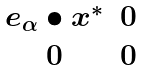Convert formula to latex. <formula><loc_0><loc_0><loc_500><loc_500>\begin{matrix} e _ { \alpha } \bullet x ^ { * } & 0 \\ 0 & 0 \end{matrix}</formula> 